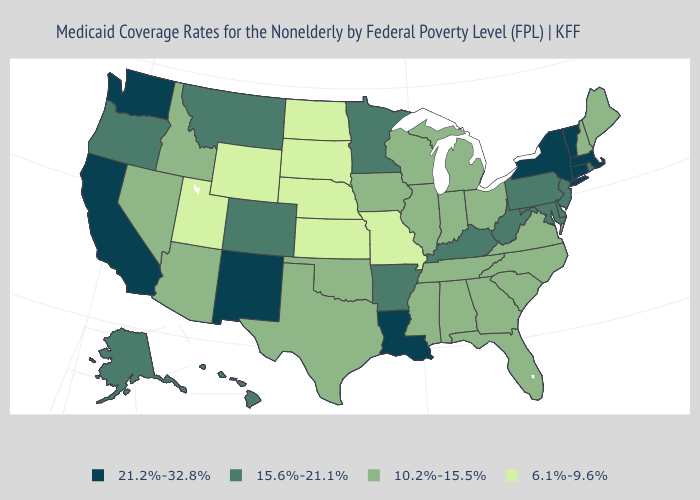Does New York have the highest value in the Northeast?
Concise answer only. Yes. Does Louisiana have the highest value in the South?
Write a very short answer. Yes. What is the highest value in the USA?
Short answer required. 21.2%-32.8%. What is the value of Alaska?
Keep it brief. 15.6%-21.1%. Which states have the highest value in the USA?
Give a very brief answer. California, Connecticut, Louisiana, Massachusetts, New Mexico, New York, Vermont, Washington. Name the states that have a value in the range 6.1%-9.6%?
Answer briefly. Kansas, Missouri, Nebraska, North Dakota, South Dakota, Utah, Wyoming. Name the states that have a value in the range 21.2%-32.8%?
Short answer required. California, Connecticut, Louisiana, Massachusetts, New Mexico, New York, Vermont, Washington. What is the value of Kentucky?
Give a very brief answer. 15.6%-21.1%. Among the states that border Utah , does Wyoming have the lowest value?
Quick response, please. Yes. What is the value of Michigan?
Write a very short answer. 10.2%-15.5%. What is the value of Delaware?
Be succinct. 15.6%-21.1%. Name the states that have a value in the range 15.6%-21.1%?
Write a very short answer. Alaska, Arkansas, Colorado, Delaware, Hawaii, Kentucky, Maryland, Minnesota, Montana, New Jersey, Oregon, Pennsylvania, Rhode Island, West Virginia. Which states have the lowest value in the USA?
Quick response, please. Kansas, Missouri, Nebraska, North Dakota, South Dakota, Utah, Wyoming. Among the states that border North Dakota , does Minnesota have the lowest value?
Answer briefly. No. How many symbols are there in the legend?
Short answer required. 4. 